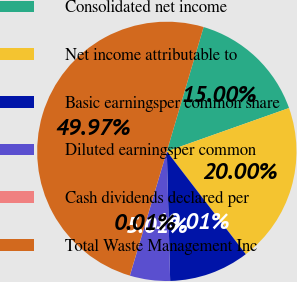<chart> <loc_0><loc_0><loc_500><loc_500><pie_chart><fcel>Consolidated net income<fcel>Net income attributable to<fcel>Basic earningsper common share<fcel>Diluted earningsper common<fcel>Cash dividends declared per<fcel>Total Waste Management Inc<nl><fcel>15.0%<fcel>20.0%<fcel>10.01%<fcel>5.01%<fcel>0.01%<fcel>49.97%<nl></chart> 